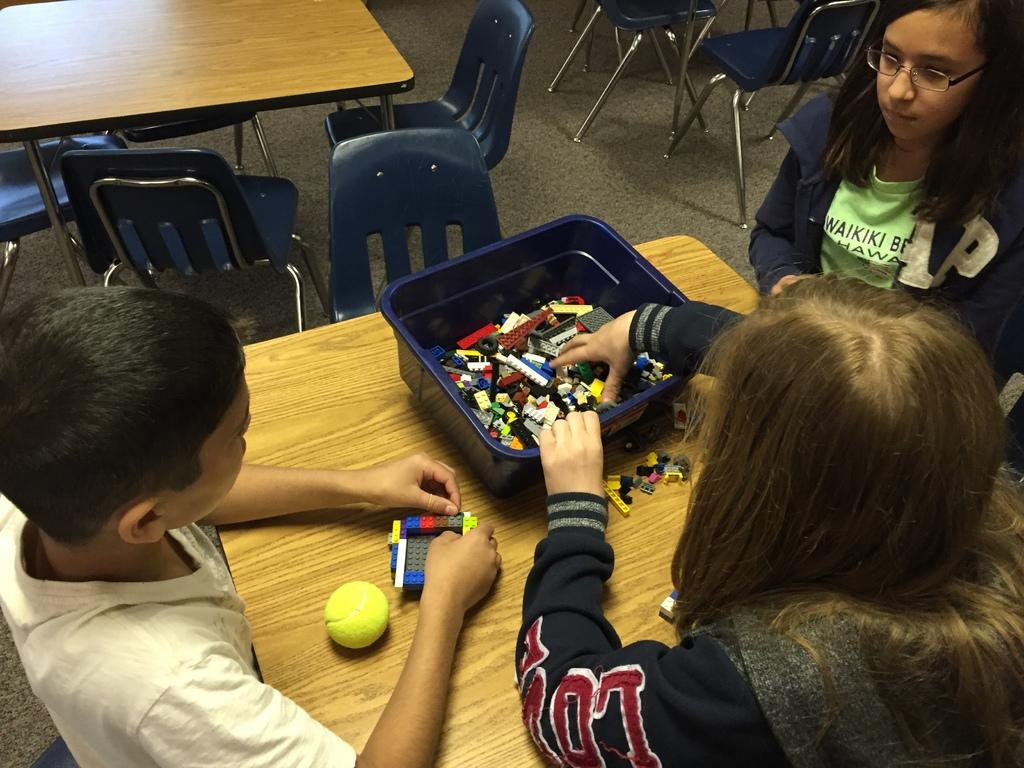How many children are present in the image? There are three children in the image. What are the children doing in the image? The children are sitting around a table and playing with toys. What type of attack is being carried out by the children in the image? There is no attack being carried out by the children in the image; they are simply playing with toys. 